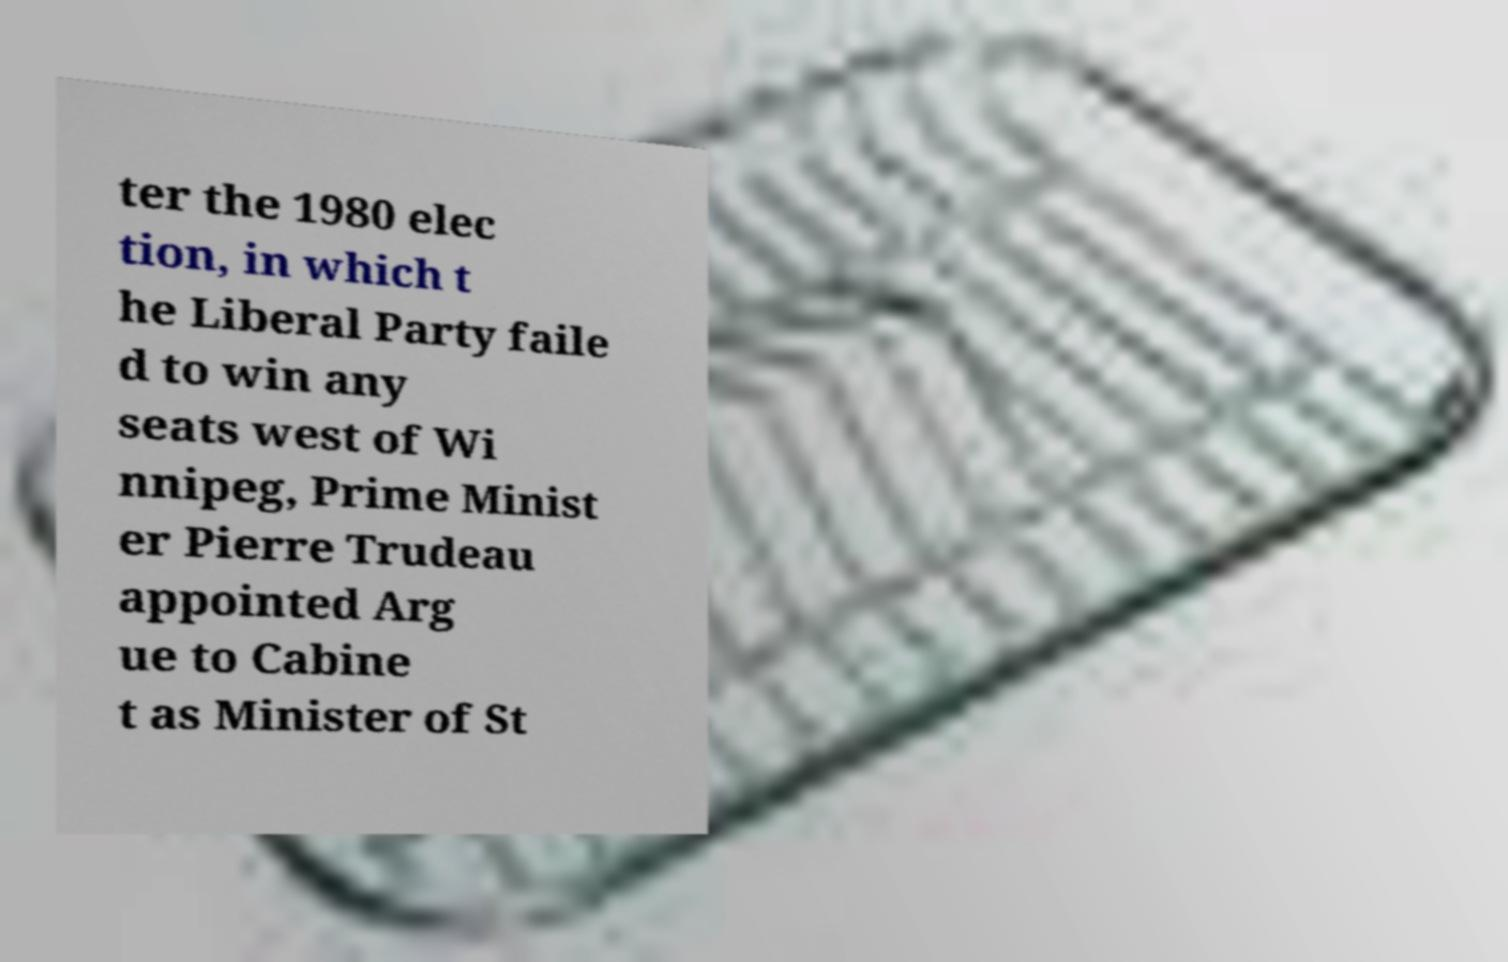Can you read and provide the text displayed in the image?This photo seems to have some interesting text. Can you extract and type it out for me? ter the 1980 elec tion, in which t he Liberal Party faile d to win any seats west of Wi nnipeg, Prime Minist er Pierre Trudeau appointed Arg ue to Cabine t as Minister of St 